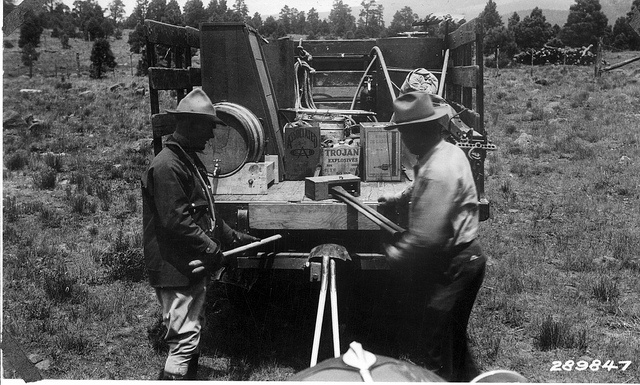Describe the objects in this image and their specific colors. I can see truck in white, black, gray, darkgray, and lightgray tones, people in white, black, gray, darkgray, and lightgray tones, and people in white, black, gray, darkgray, and lightgray tones in this image. 